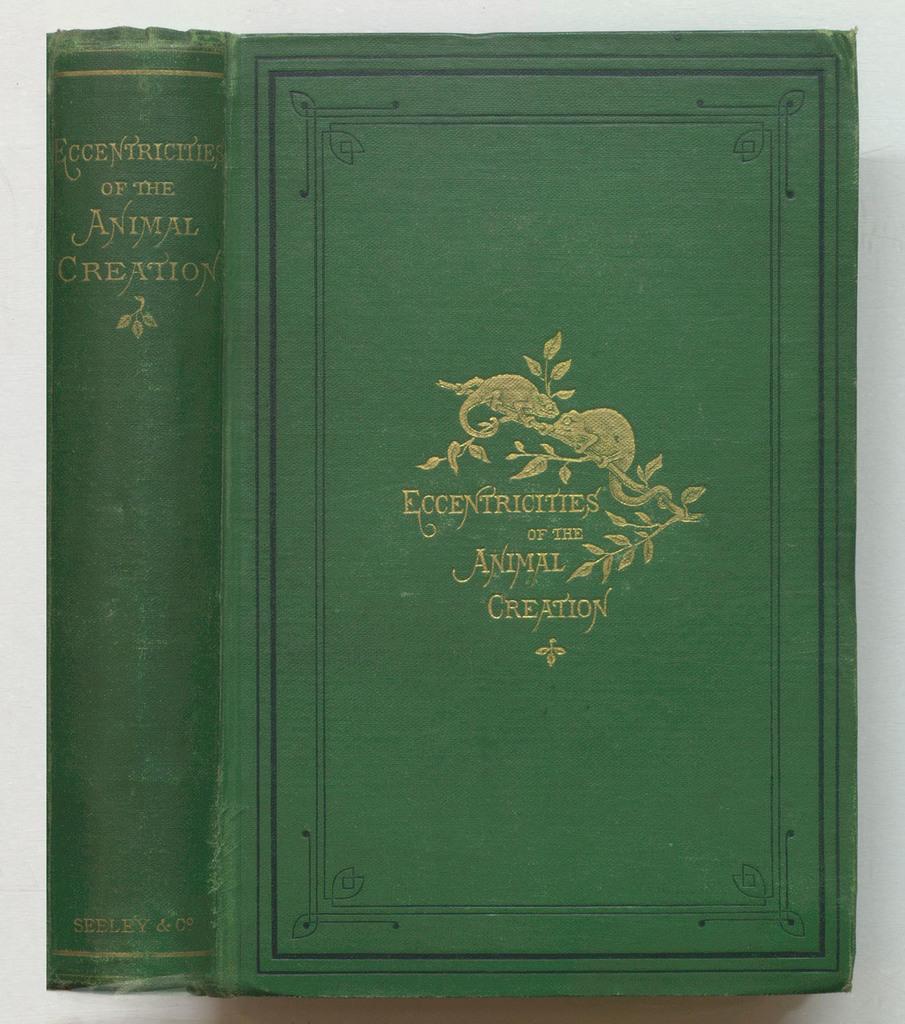Who is the author of the book?
Your answer should be compact. Seeley & co. 